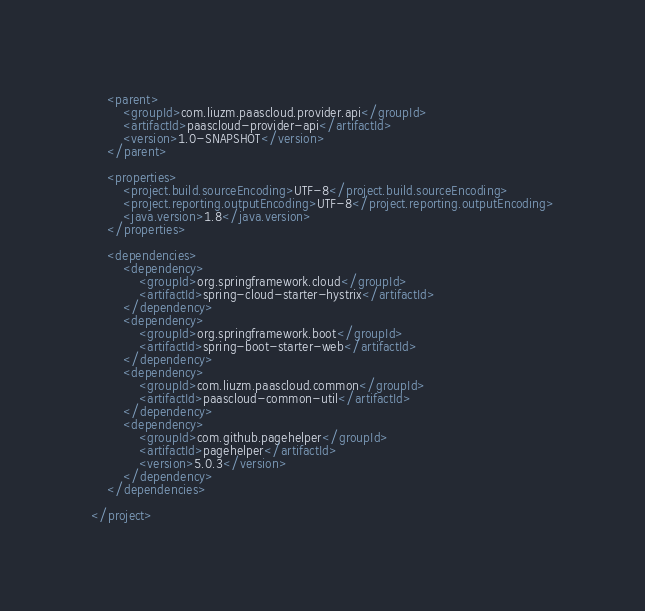<code> <loc_0><loc_0><loc_500><loc_500><_XML_>    <parent>
        <groupId>com.liuzm.paascloud.provider.api</groupId>
        <artifactId>paascloud-provider-api</artifactId>
        <version>1.0-SNAPSHOT</version>
    </parent>

	<properties>
		<project.build.sourceEncoding>UTF-8</project.build.sourceEncoding>
		<project.reporting.outputEncoding>UTF-8</project.reporting.outputEncoding>
		<java.version>1.8</java.version>
	</properties>

	<dependencies>
		<dependency>
			<groupId>org.springframework.cloud</groupId>
			<artifactId>spring-cloud-starter-hystrix</artifactId>
		</dependency>
		<dependency>
			<groupId>org.springframework.boot</groupId>
			<artifactId>spring-boot-starter-web</artifactId>
		</dependency>
        <dependency>
            <groupId>com.liuzm.paascloud.common</groupId>
            <artifactId>paascloud-common-util</artifactId>
        </dependency>
        <dependency>
            <groupId>com.github.pagehelper</groupId>
            <artifactId>pagehelper</artifactId>
            <version>5.0.3</version>
        </dependency>
    </dependencies>

</project>
</code> 